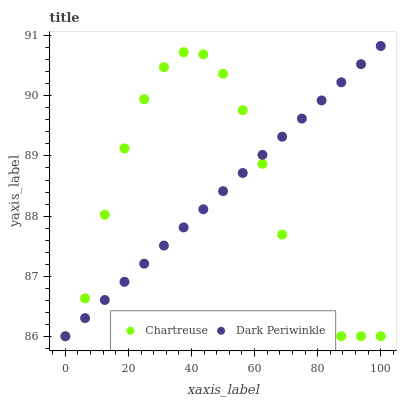Does Chartreuse have the minimum area under the curve?
Answer yes or no. Yes. Does Dark Periwinkle have the maximum area under the curve?
Answer yes or no. Yes. Does Dark Periwinkle have the minimum area under the curve?
Answer yes or no. No. Is Dark Periwinkle the smoothest?
Answer yes or no. Yes. Is Chartreuse the roughest?
Answer yes or no. Yes. Is Dark Periwinkle the roughest?
Answer yes or no. No. Does Chartreuse have the lowest value?
Answer yes or no. Yes. Does Dark Periwinkle have the highest value?
Answer yes or no. Yes. Does Chartreuse intersect Dark Periwinkle?
Answer yes or no. Yes. Is Chartreuse less than Dark Periwinkle?
Answer yes or no. No. Is Chartreuse greater than Dark Periwinkle?
Answer yes or no. No. 